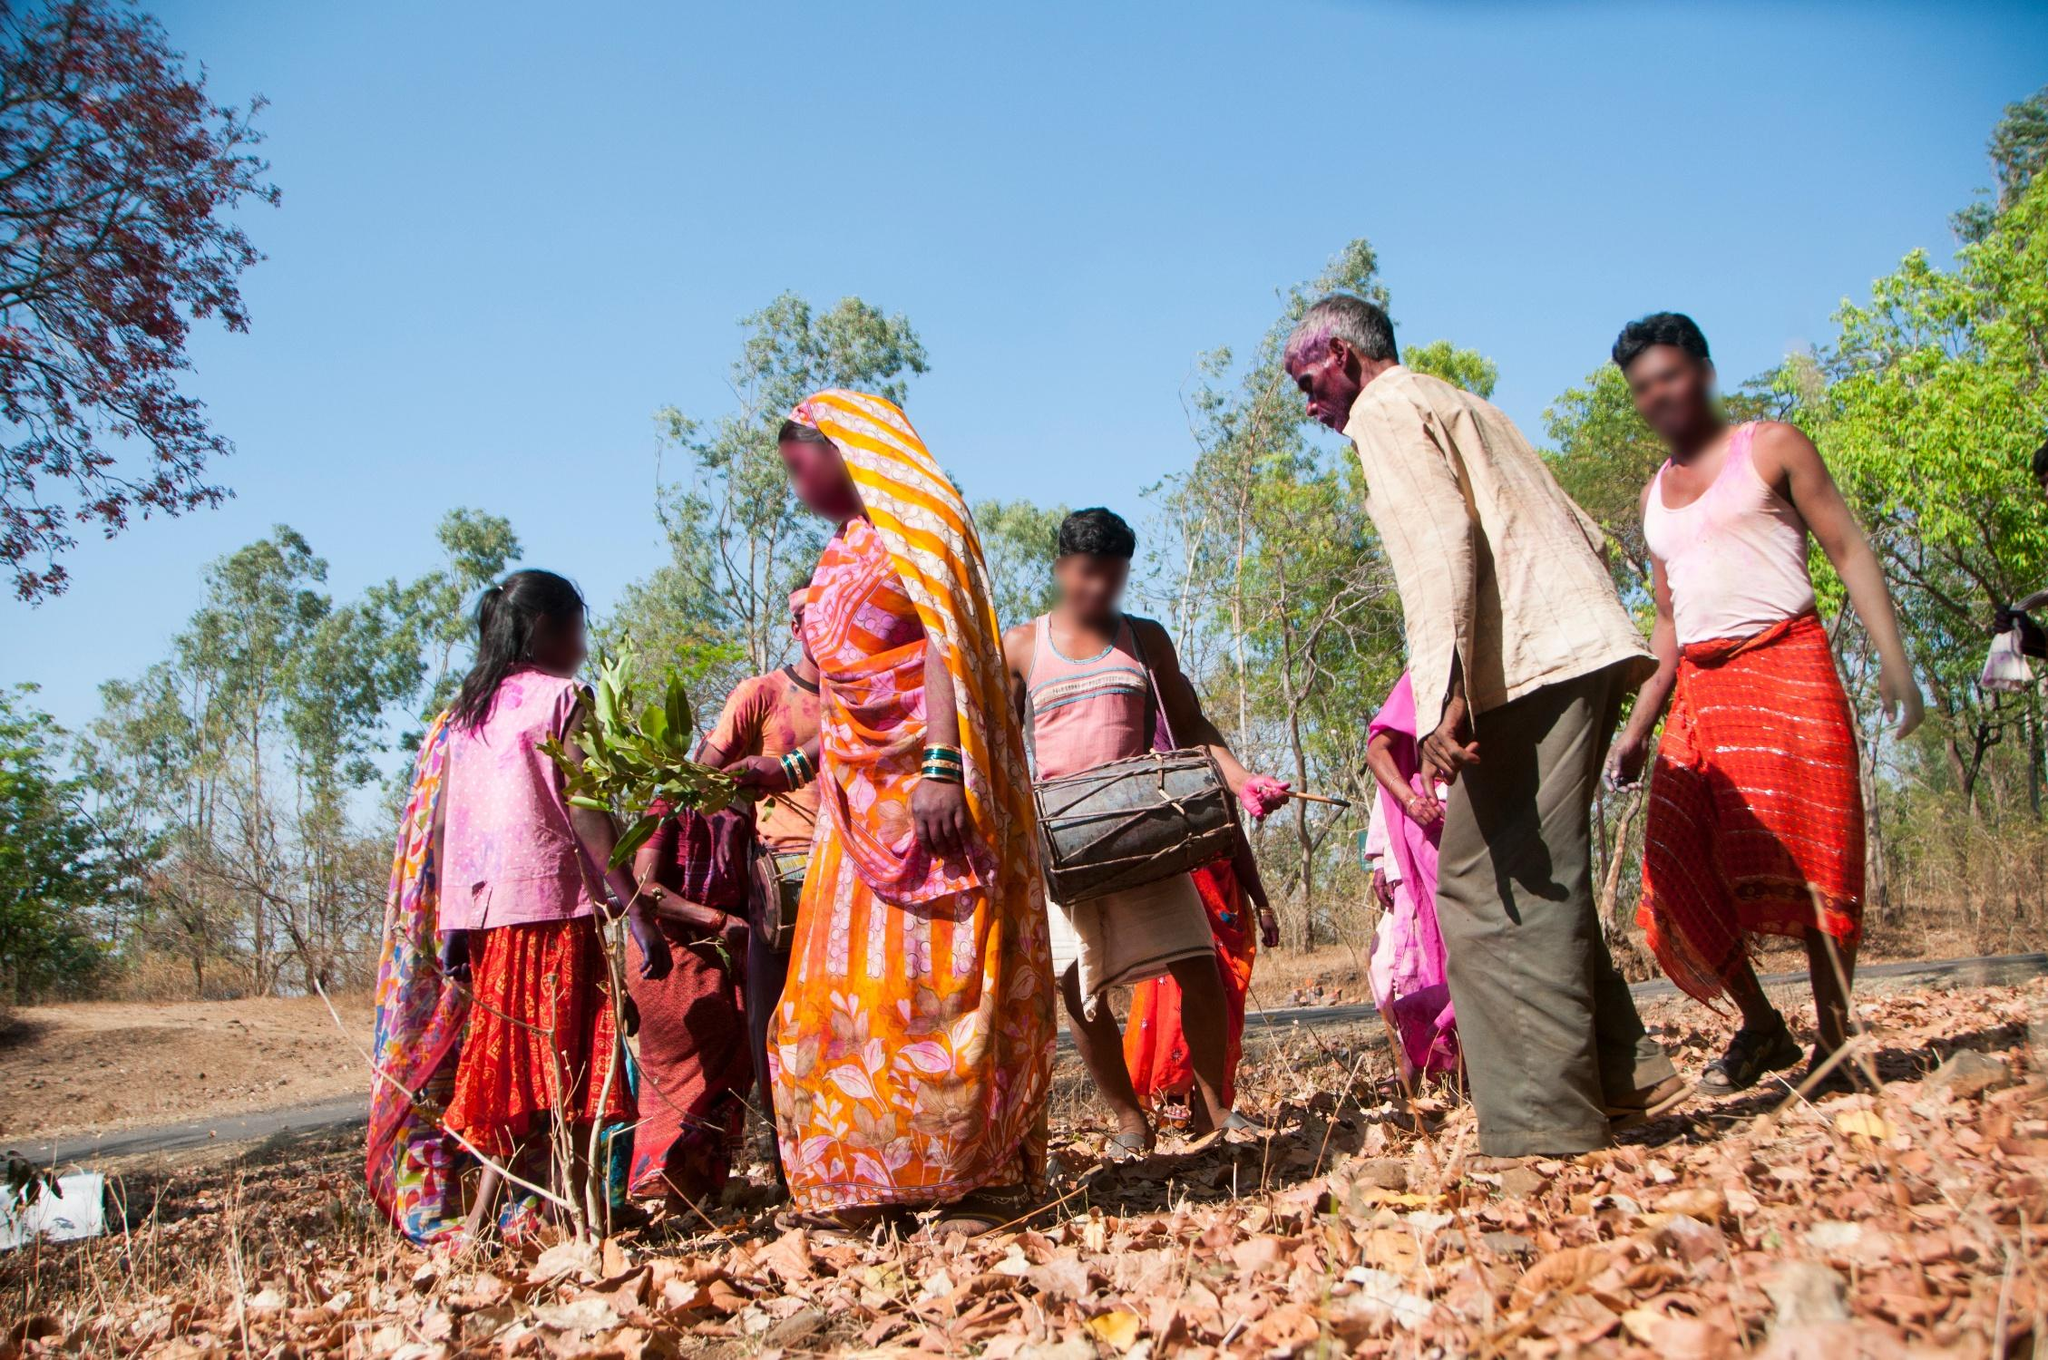Imagine if the people in this image were preparing for an interstellar journey. What would their mission be, and how would they prepare? In a fantastical twist, the people in the image are actually a part of a unique cultural delegation selected for an interstellar mission to represent Earth’s diverse traditions. Their mission is to share their agricultural knowledge and vibrant cultural heritage with an alien civilization on a distant planet. Preparing for the journey, they engage in rigorous training, learn advanced space farming techniques, and practice rituals to adapt their traditions to a zero-gravity environment. As they embark, their colorful attire is transformed into specially designed space suits that still reflect their cultural identity, making them ambassadors of Earth's rich diversity among the stars. 